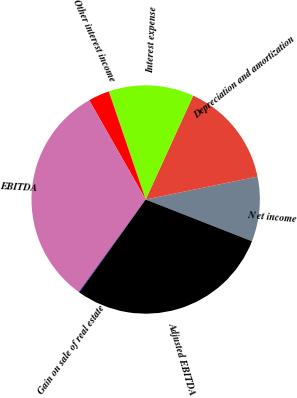<chart> <loc_0><loc_0><loc_500><loc_500><pie_chart><fcel>N et income<fcel>Depreciation and amortization<fcel>Interest expense<fcel>Other interest income<fcel>EBITDA<fcel>Gain on sale of real estate<fcel>Adjusted EBITDA<nl><fcel>9.17%<fcel>14.95%<fcel>12.06%<fcel>3.0%<fcel>31.79%<fcel>0.11%<fcel>28.9%<nl></chart> 